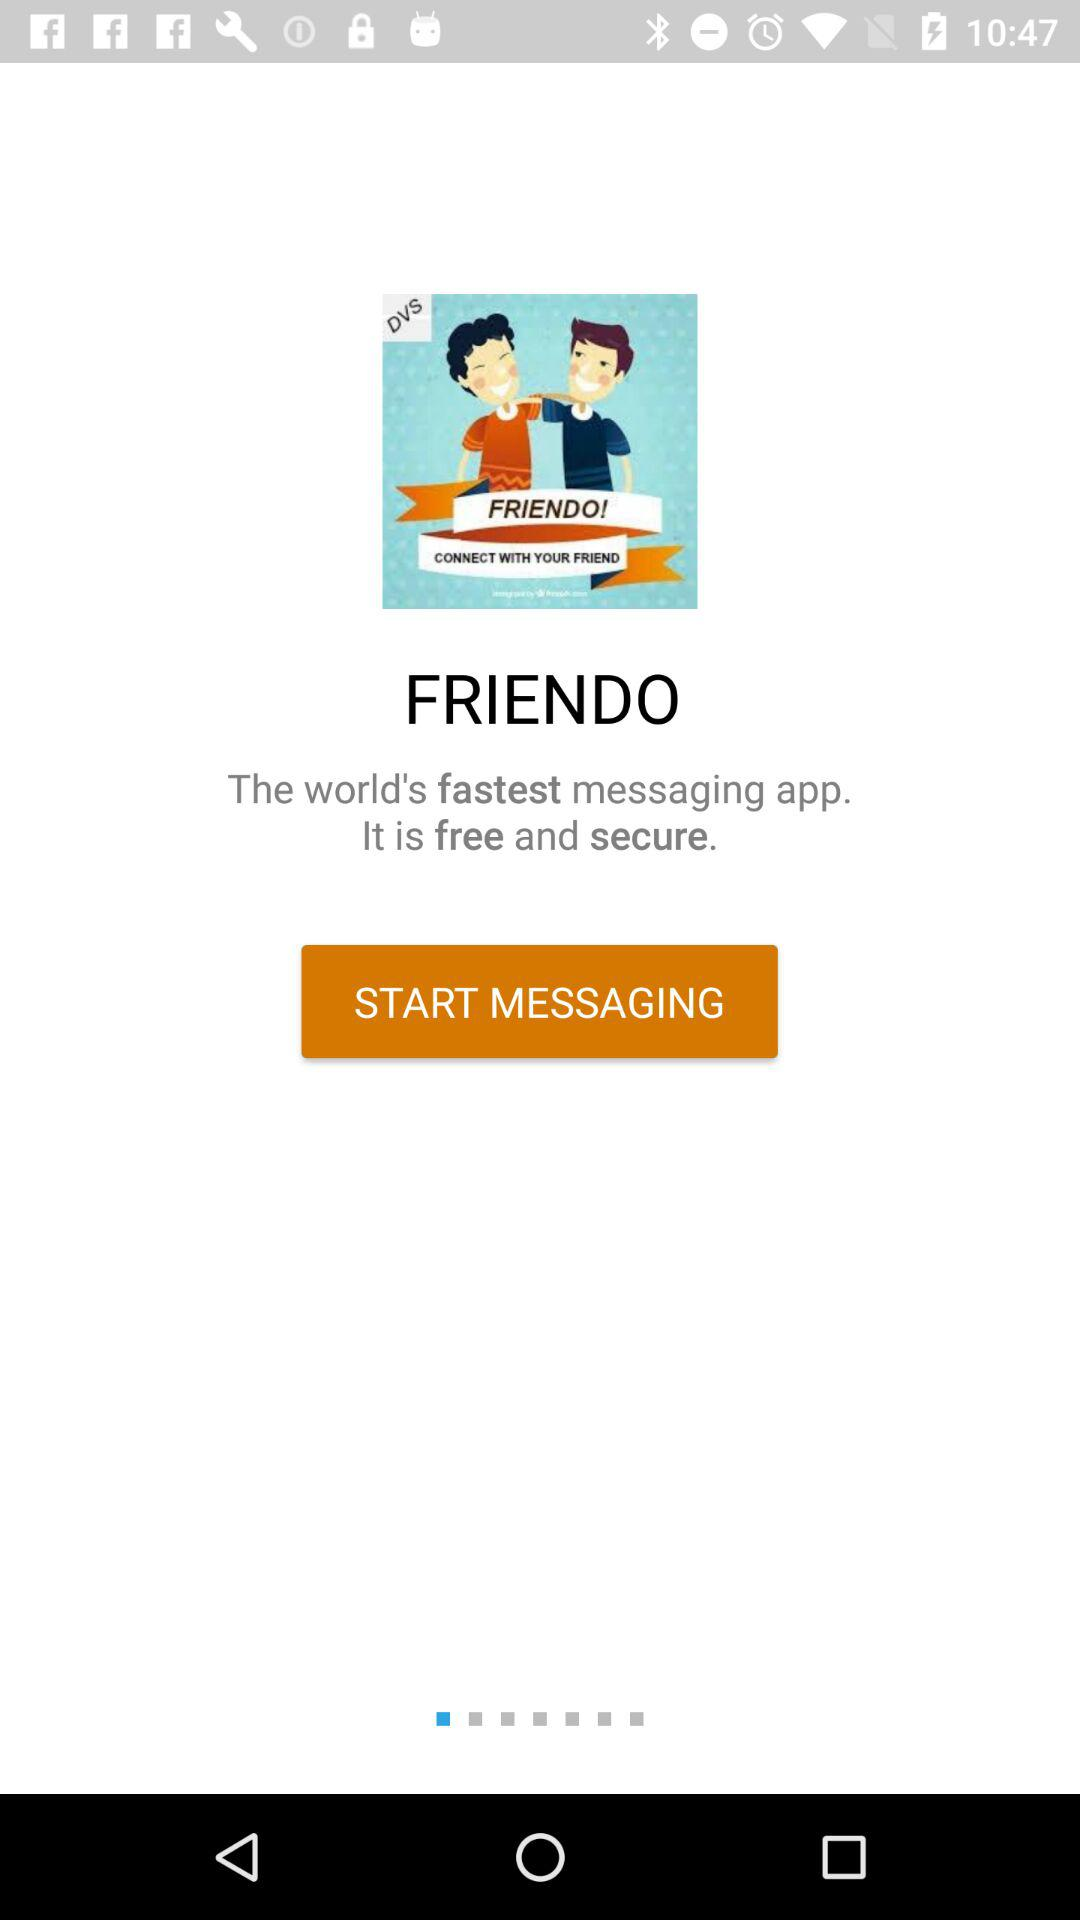What is the name of the application? The name of the application is "FRIENDO". 